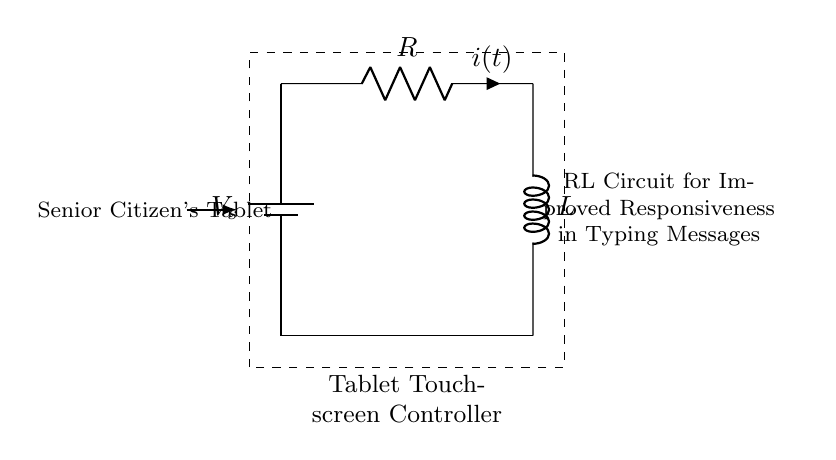What is the type of the circuit depicted? The circuit is an RL circuit, which consists of a resistor and an inductor connected in series.
Answer: RL circuit What is the role of the depicted resistive element? The resistor limits the current flow and dissipates energy in the form of heat, helping control the responsiveness of the touch controller.
Answer: Current control What is denoted by the symbol V_s in the circuit? V_s represents the voltage source supplying power to the RL circuit. It is the input voltage needed for operation.
Answer: Voltage source What happens to the current when the switch is closed? When the switch is closed, the current starts to increase through the resistor and inductor, initially at a slower rate due to the inductance, leading to a steady state after some time.
Answer: Current increases How does the inductor affect the response time in the touchscreen controller? The inductor introduces a delay in current change due to its property of opposing changes in current, which helps stabilize the response against rapid fluctuations when typing.
Answer: Delays response What is the relationship between resistance and responsiveness in this circuit? Higher resistance reduces current flow, leading to slower response times, while lower resistance allows more current, thus enhancing responsiveness in typing.
Answer: Inverse relationship What is the main purpose of this RL circuit in a tablet? The main purpose is to enhance the responsiveness of the touchscreen when typing messages by stabilizing current flow through the controller.
Answer: Improved responsiveness 